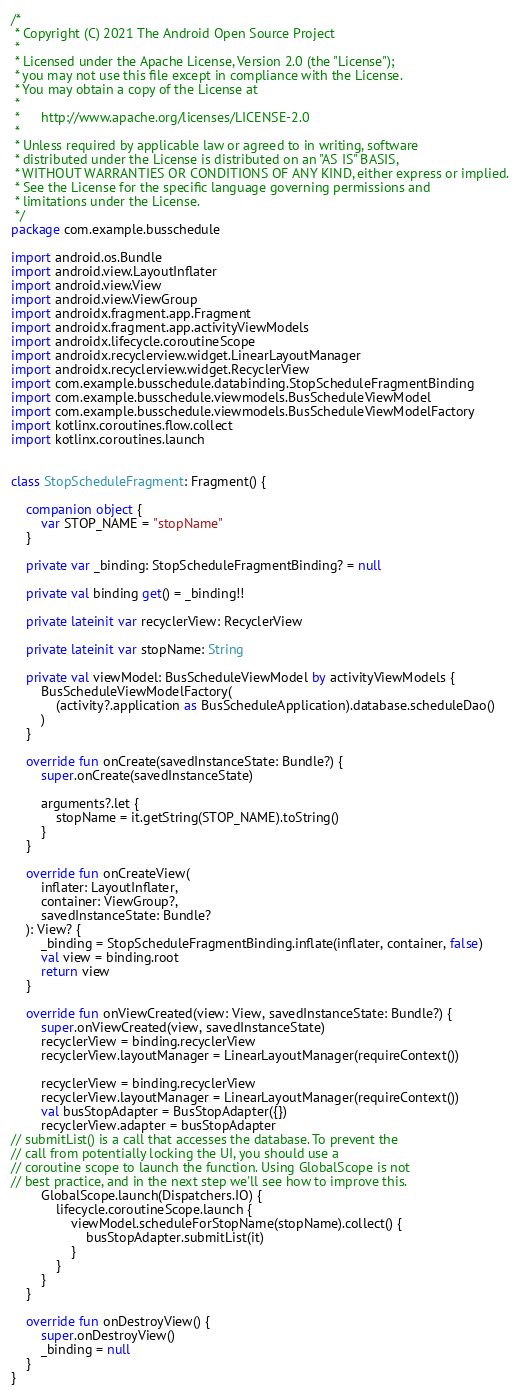Convert code to text. <code><loc_0><loc_0><loc_500><loc_500><_Kotlin_>/*
 * Copyright (C) 2021 The Android Open Source Project
 *
 * Licensed under the Apache License, Version 2.0 (the "License");
 * you may not use this file except in compliance with the License.
 * You may obtain a copy of the License at
 *
 *      http://www.apache.org/licenses/LICENSE-2.0
 *
 * Unless required by applicable law or agreed to in writing, software
 * distributed under the License is distributed on an "AS IS" BASIS,
 * WITHOUT WARRANTIES OR CONDITIONS OF ANY KIND, either express or implied.
 * See the License for the specific language governing permissions and
 * limitations under the License.
 */
package com.example.busschedule

import android.os.Bundle
import android.view.LayoutInflater
import android.view.View
import android.view.ViewGroup
import androidx.fragment.app.Fragment
import androidx.fragment.app.activityViewModels
import androidx.lifecycle.coroutineScope
import androidx.recyclerview.widget.LinearLayoutManager
import androidx.recyclerview.widget.RecyclerView
import com.example.busschedule.databinding.StopScheduleFragmentBinding
import com.example.busschedule.viewmodels.BusScheduleViewModel
import com.example.busschedule.viewmodels.BusScheduleViewModelFactory
import kotlinx.coroutines.flow.collect
import kotlinx.coroutines.launch


class StopScheduleFragment: Fragment() {

    companion object {
        var STOP_NAME = "stopName"
    }

    private var _binding: StopScheduleFragmentBinding? = null

    private val binding get() = _binding!!

    private lateinit var recyclerView: RecyclerView

    private lateinit var stopName: String

    private val viewModel: BusScheduleViewModel by activityViewModels {
        BusScheduleViewModelFactory(
            (activity?.application as BusScheduleApplication).database.scheduleDao()
        )
    }

    override fun onCreate(savedInstanceState: Bundle?) {
        super.onCreate(savedInstanceState)

        arguments?.let {
            stopName = it.getString(STOP_NAME).toString()
        }
    }

    override fun onCreateView(
        inflater: LayoutInflater,
        container: ViewGroup?,
        savedInstanceState: Bundle?
    ): View? {
        _binding = StopScheduleFragmentBinding.inflate(inflater, container, false)
        val view = binding.root
        return view
    }

    override fun onViewCreated(view: View, savedInstanceState: Bundle?) {
        super.onViewCreated(view, savedInstanceState)
        recyclerView = binding.recyclerView
        recyclerView.layoutManager = LinearLayoutManager(requireContext())

        recyclerView = binding.recyclerView
        recyclerView.layoutManager = LinearLayoutManager(requireContext())
        val busStopAdapter = BusStopAdapter({})
        recyclerView.adapter = busStopAdapter
// submitList() is a call that accesses the database. To prevent the
// call from potentially locking the UI, you should use a
// coroutine scope to launch the function. Using GlobalScope is not
// best practice, and in the next step we'll see how to improve this.
        GlobalScope.launch(Dispatchers.IO) {
            lifecycle.coroutineScope.launch {
                viewModel.scheduleForStopName(stopName).collect() {
                    busStopAdapter.submitList(it)
                }
            }
        }
    }

    override fun onDestroyView() {
        super.onDestroyView()
        _binding = null
    }
}
</code> 